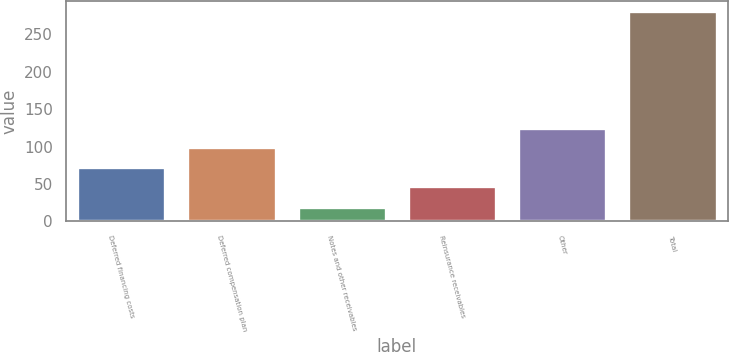Convert chart. <chart><loc_0><loc_0><loc_500><loc_500><bar_chart><fcel>Deferred financing costs<fcel>Deferred compensation plan<fcel>Notes and other receivables<fcel>Reinsurance receivables<fcel>Other<fcel>Total<nl><fcel>73.04<fcel>99.18<fcel>19.5<fcel>46.9<fcel>125.32<fcel>280.9<nl></chart> 